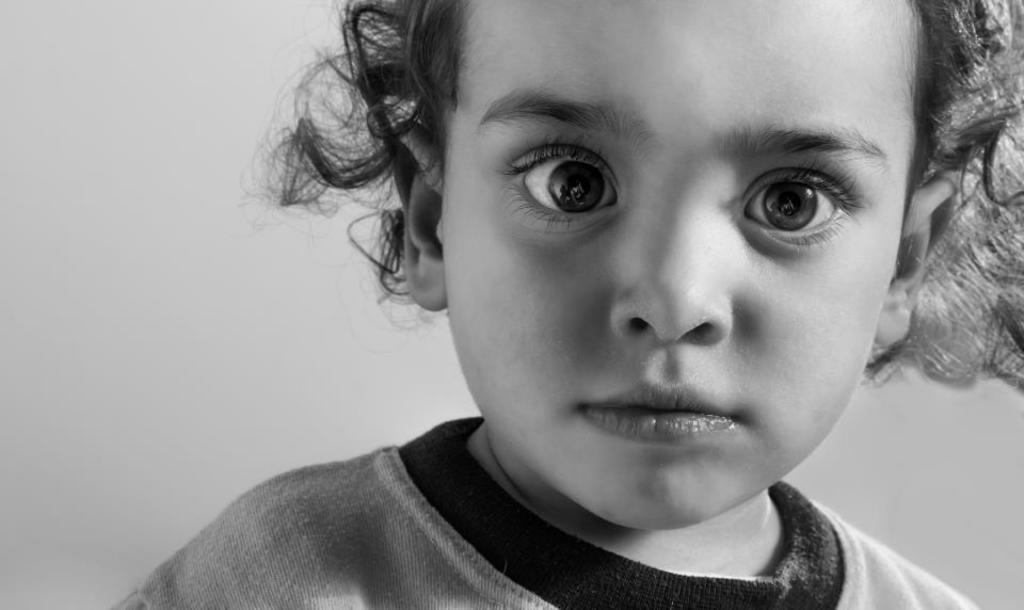How would you summarize this image in a sentence or two? Here in this picture we can see a child in a close up view. 